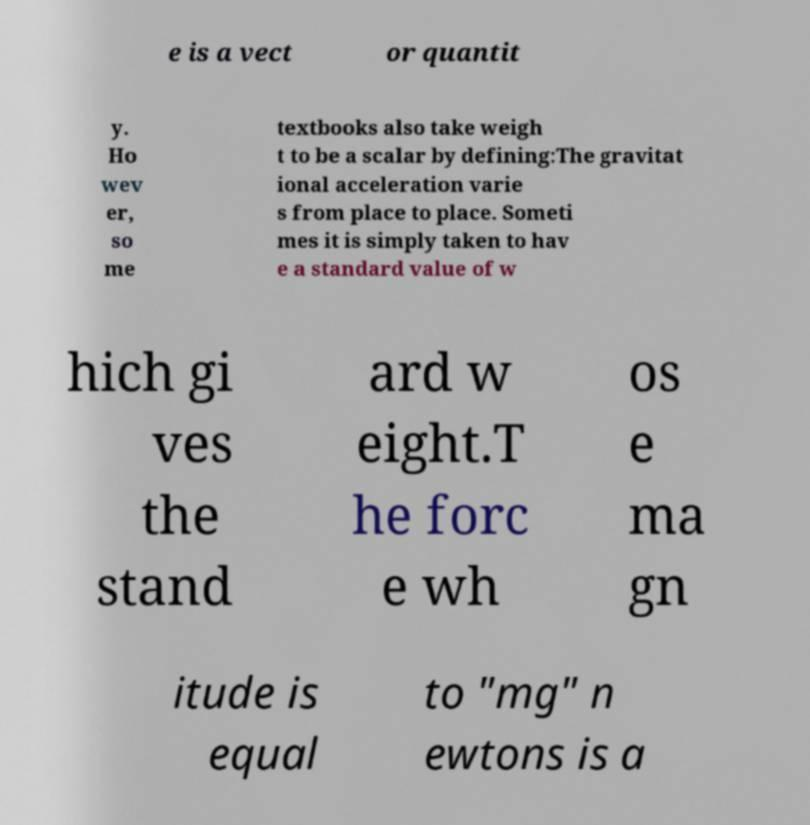What might be the implications of using a standard value for weight calculations? Using a standard value for weight simplifies calculations in many scenarios, making educational and practical applications more straightforward. However, it can introduce errors in precision contexts, such as engineering calculations or scientific measurements, where local variations in gravitational pull are significant. 